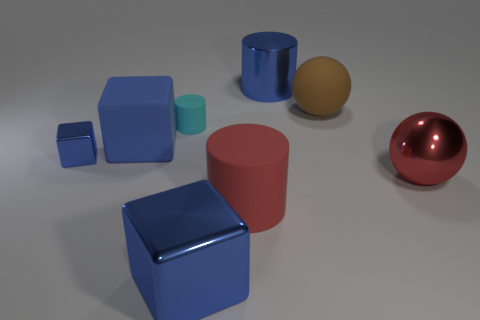What time of day does the lighting in this image suggest? The diffuse, soft shadows and neutral color temperature of the lighting in this image suggest an artificial indoor setting, rather than a specific time of day. It looks like the scene may be lit by overhead lights typically found in an interior space. 